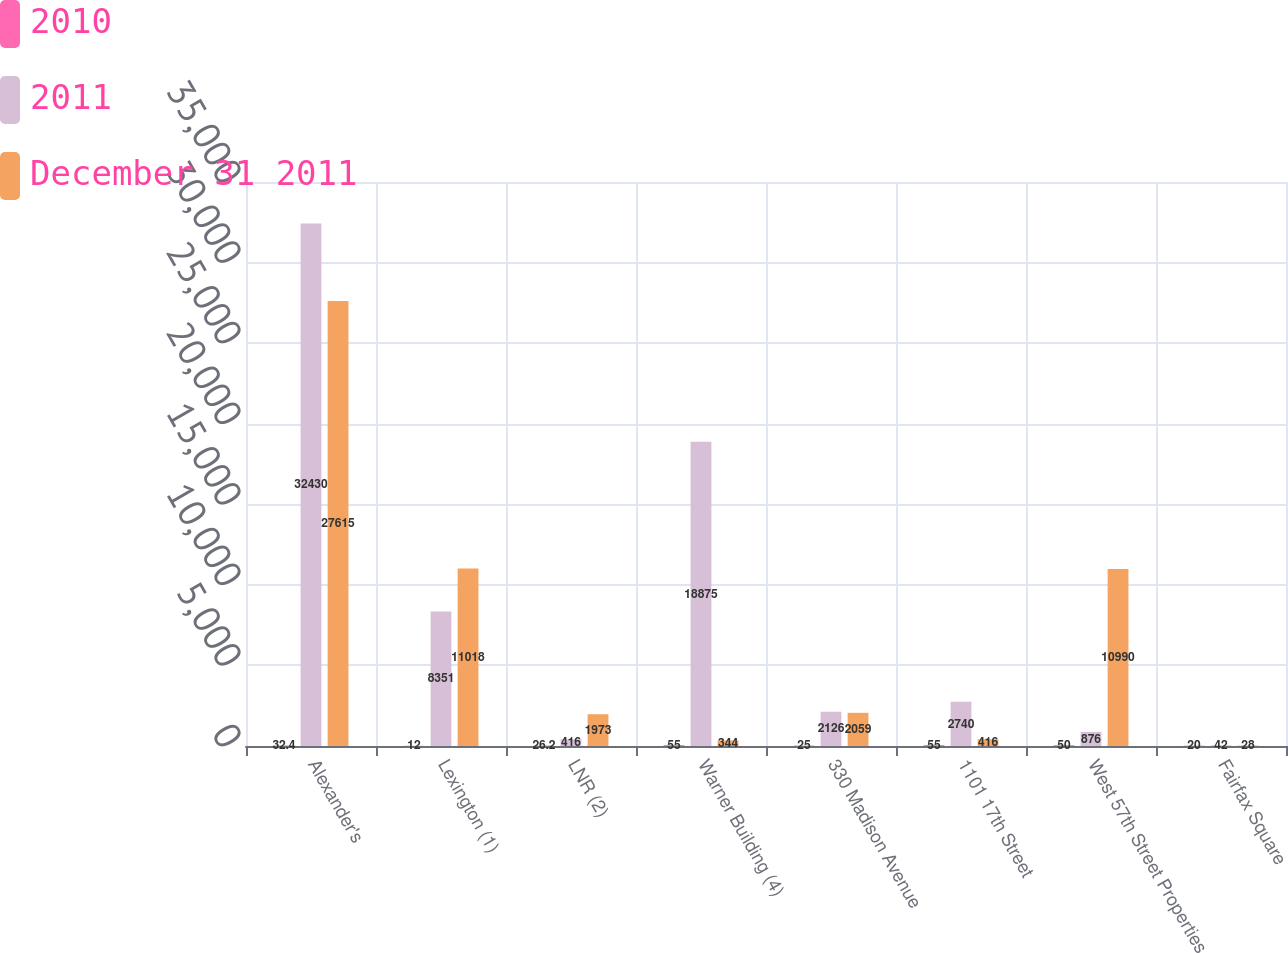<chart> <loc_0><loc_0><loc_500><loc_500><stacked_bar_chart><ecel><fcel>Alexander's<fcel>Lexington (1)<fcel>LNR (2)<fcel>Warner Building (4)<fcel>330 Madison Avenue<fcel>1101 17th Street<fcel>West 57th Street Properties<fcel>Fairfax Square<nl><fcel>2010<fcel>32.4<fcel>12<fcel>26.2<fcel>55<fcel>25<fcel>55<fcel>50<fcel>20<nl><fcel>2011<fcel>32430<fcel>8351<fcel>416<fcel>18875<fcel>2126<fcel>2740<fcel>876<fcel>42<nl><fcel>December 31 2011<fcel>27615<fcel>11018<fcel>1973<fcel>344<fcel>2059<fcel>416<fcel>10990<fcel>28<nl></chart> 